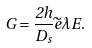Convert formula to latex. <formula><loc_0><loc_0><loc_500><loc_500>G = \frac { 2 h } { D _ { s } } \widetilde { e } \lambda E .</formula> 